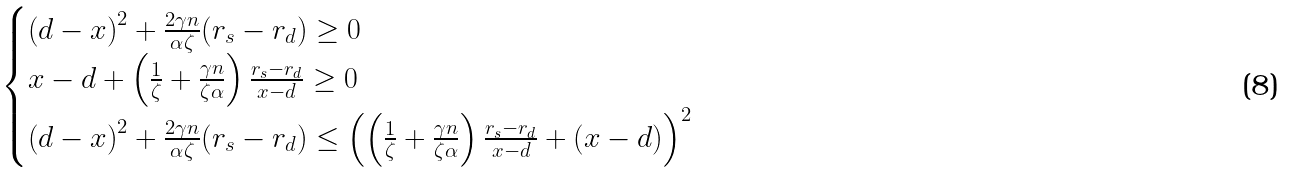Convert formula to latex. <formula><loc_0><loc_0><loc_500><loc_500>\begin{cases} \left ( d - x \right ) ^ { 2 } + \frac { 2 \gamma n } { \alpha \zeta } ( r _ { s } - r _ { d } ) \geq 0 \\ x - d + \left ( \frac { 1 } { \zeta } + \frac { \gamma n } { \zeta \alpha } \right ) \frac { r _ { s } - r _ { d } } { x - d } \geq 0 \\ \left ( d - x \right ) ^ { 2 } + \frac { 2 \gamma n } { \alpha \zeta } ( r _ { s } - r _ { d } ) \leq \left ( \left ( \frac { 1 } { \zeta } + \frac { \gamma n } { \zeta \alpha } \right ) \frac { r _ { s } - r _ { d } } { x - d } + \left ( x - d \right ) \right ) ^ { 2 } \end{cases}</formula> 